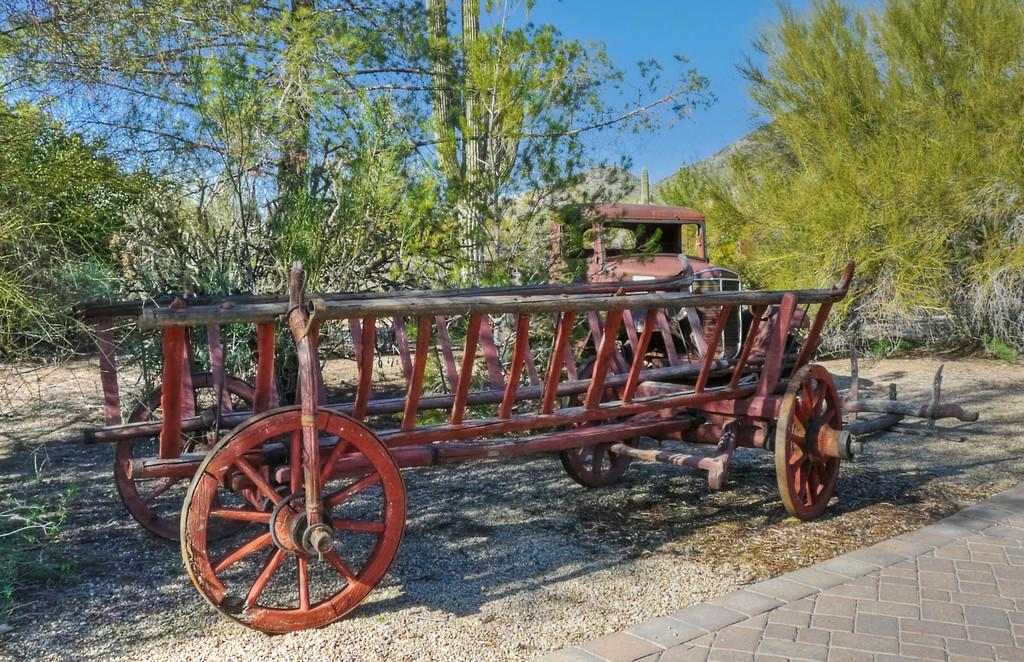What type of vehicle is in the image? There is a wheel cart in the image. What other objects can be seen in the image? There are trees, a cactus plant, and a path visible in the image. What is the color of the sky in the image? The sky is blue in color. Where is the path located in the image? The path is visible in the bottom right of the image. What is the price of the cactus plant in the image? There is no price mentioned or visible in the image, so it cannot be determined. 